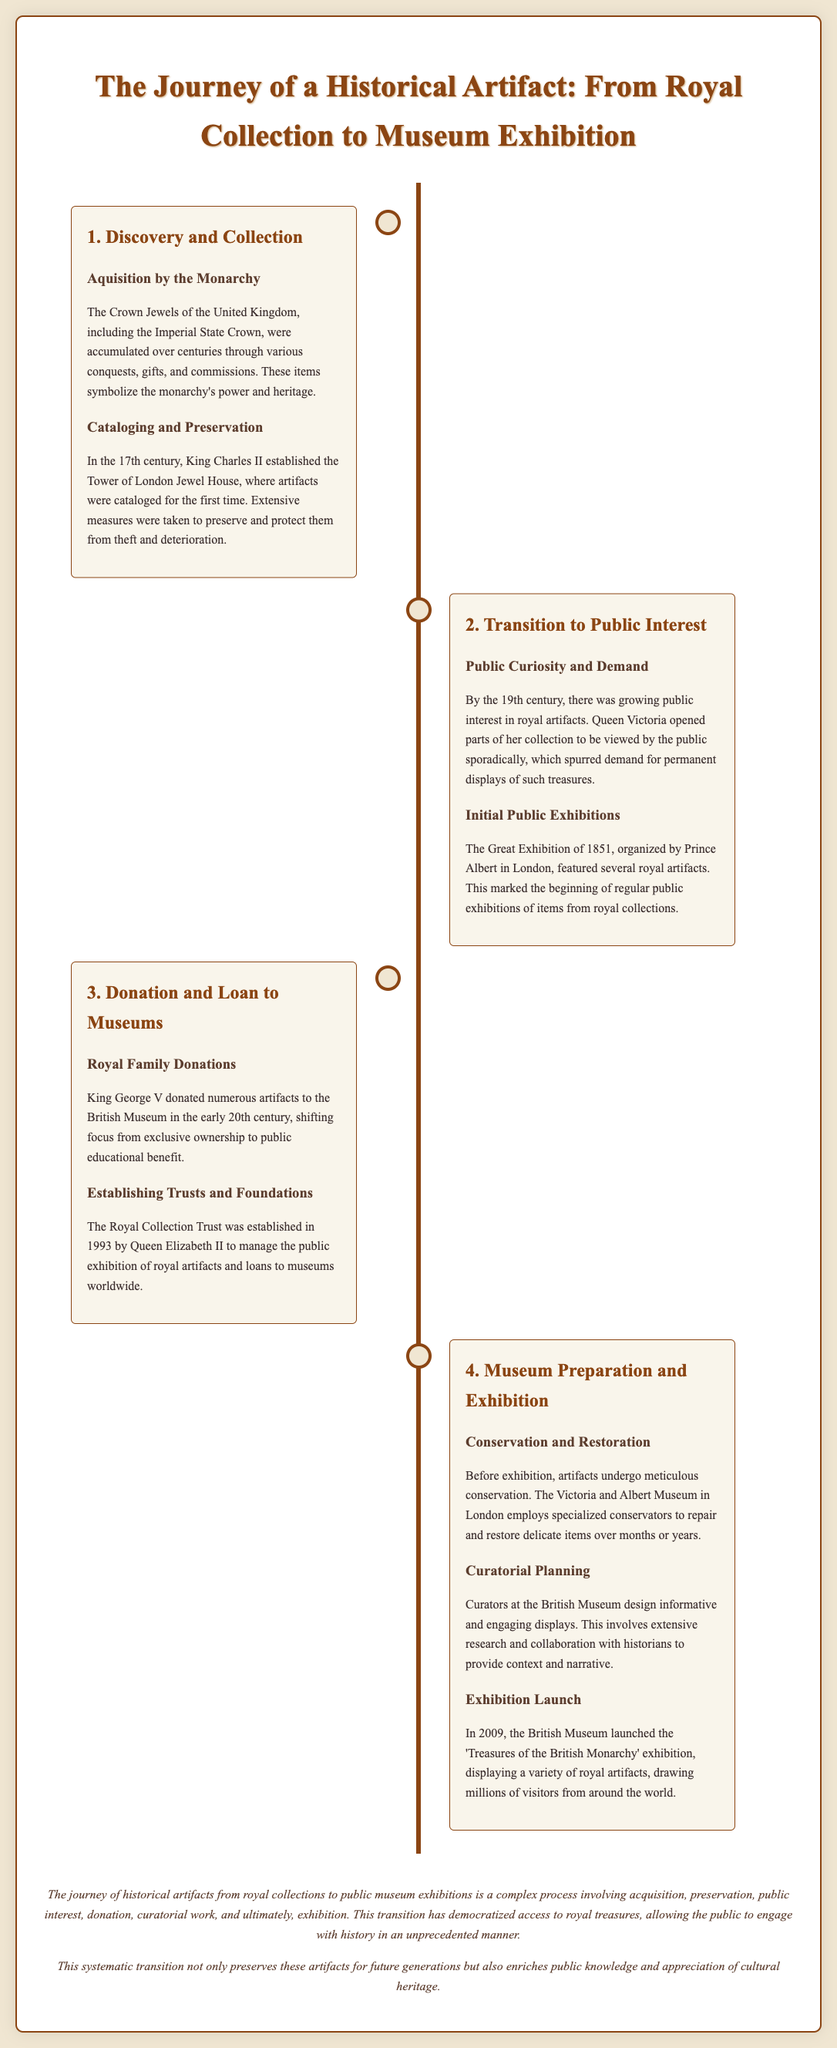What are the Crown Jewels of the United Kingdom? The Crown Jewels include the Imperial State Crown, among other artifacts that symbolize the monarchy's power and heritage.
Answer: The Imperial State Crown Who established the Tower of London Jewel House? The Tower of London Jewel House was established by King Charles II in the 17th century.
Answer: King Charles II What significant exhibition was organized by Prince Albert? The Great Exhibition of 1851 featured several royal artifacts and marked the beginning of regular public exhibitions.
Answer: The Great Exhibition of 1851 Which royal donated numerous artifacts to the British Museum? King George V donated numerous artifacts in the early 20th century.
Answer: King George V What does the Royal Collection Trust manage? The Royal Collection Trust manages the public exhibition of royal artifacts and loans to museums worldwide.
Answer: Public exhibition and loans When was the 'Treasures of the British Monarchy' exhibition launched? The exhibition was launched in 2009 at the British Museum.
Answer: 2009 What role do curators play in the exhibition process? Curators design informative and engaging displays, requiring extensive research and collaboration with historians.
Answer: Informative and engaging displays How has the transition of artifacts from collections to exhibitions benefited the public? This transition has democratized access to royal treasures, enriching public knowledge and appreciation of cultural heritage.
Answer: Democratized access to royal treasures 